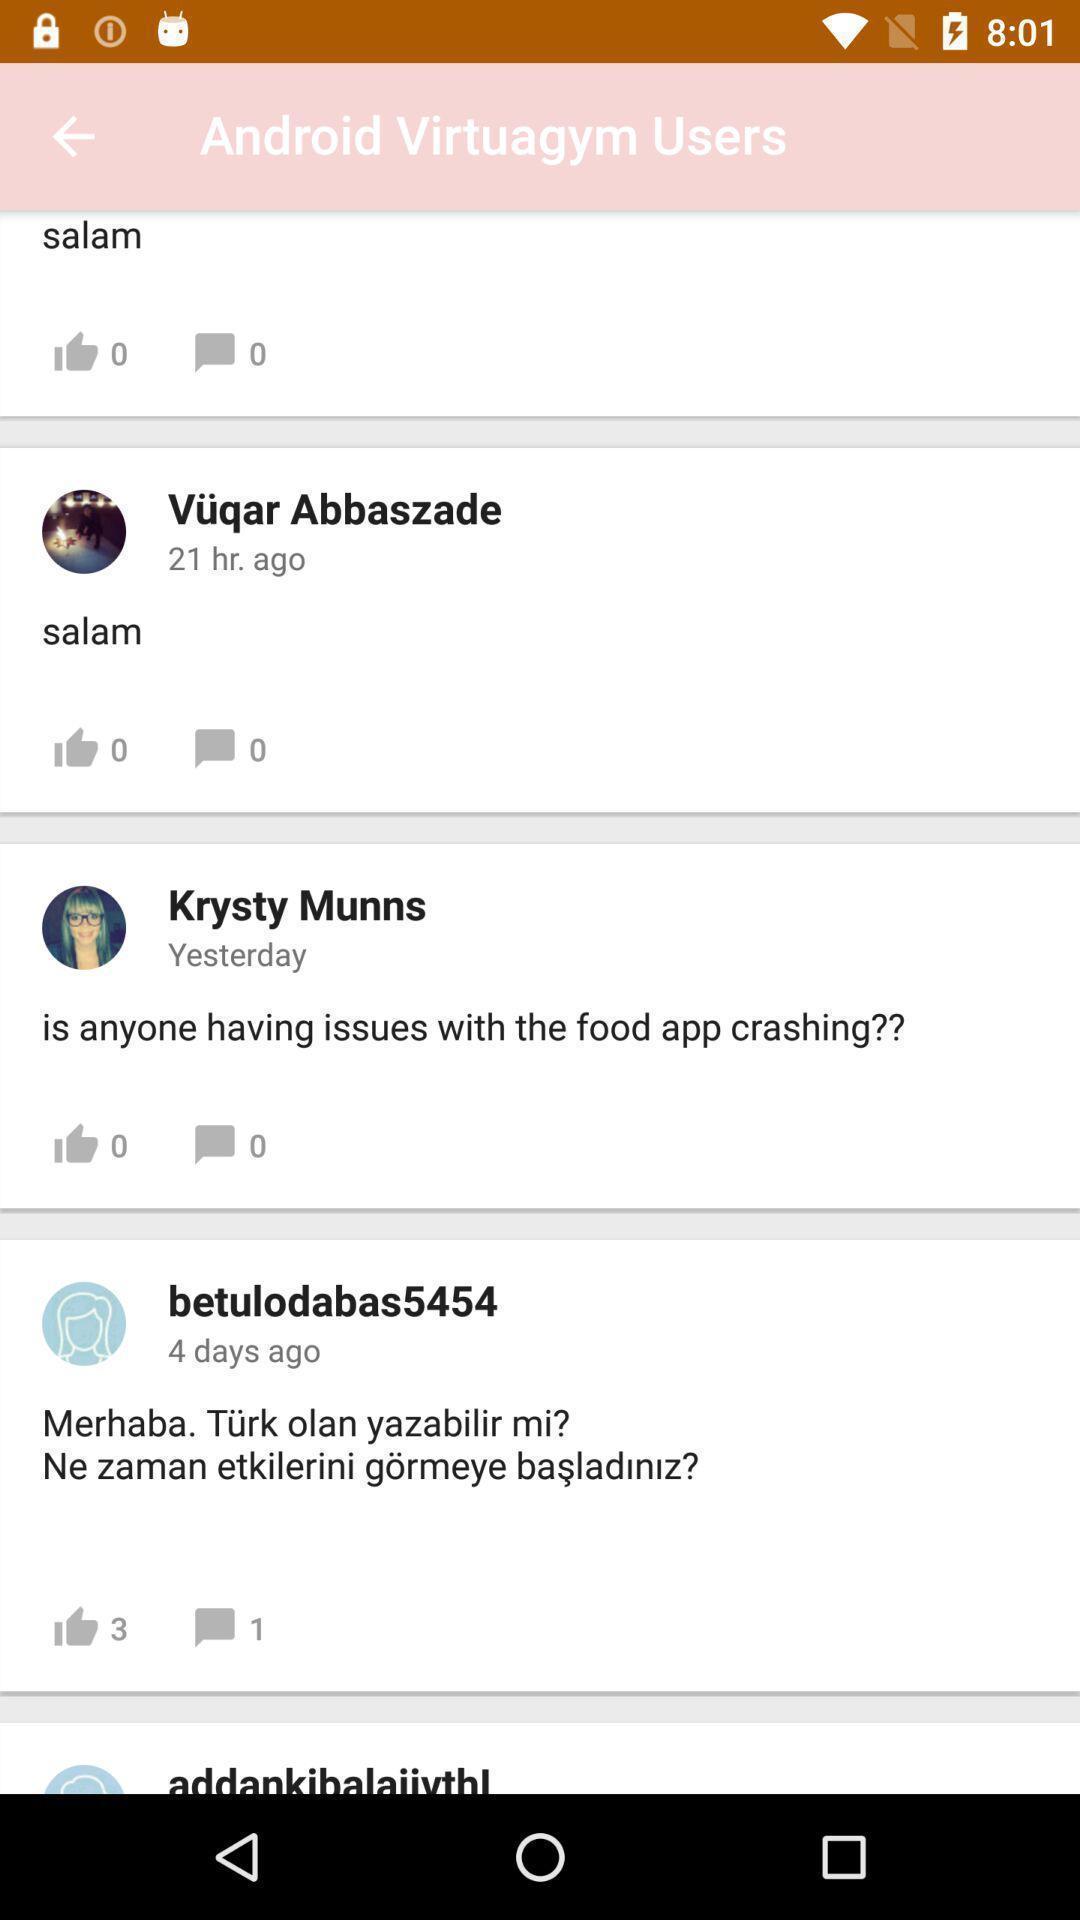Explain what's happening in this screen capture. Page showing post 's. 